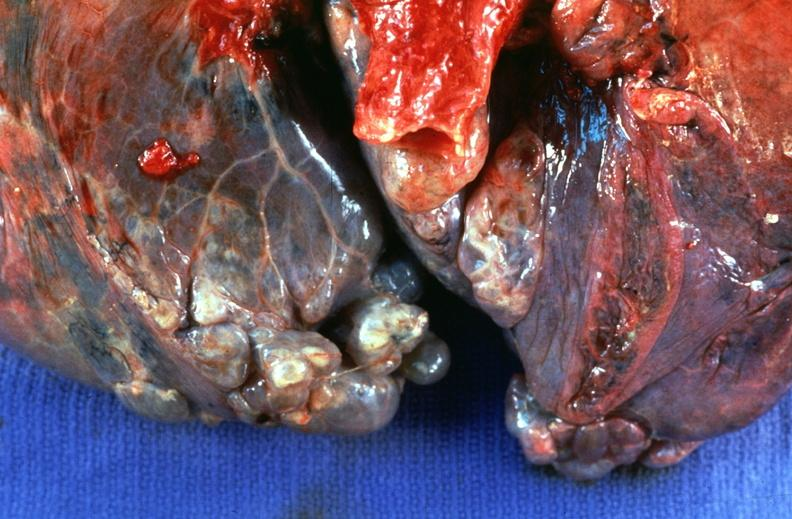where is this?
Answer the question using a single word or phrase. Lung 